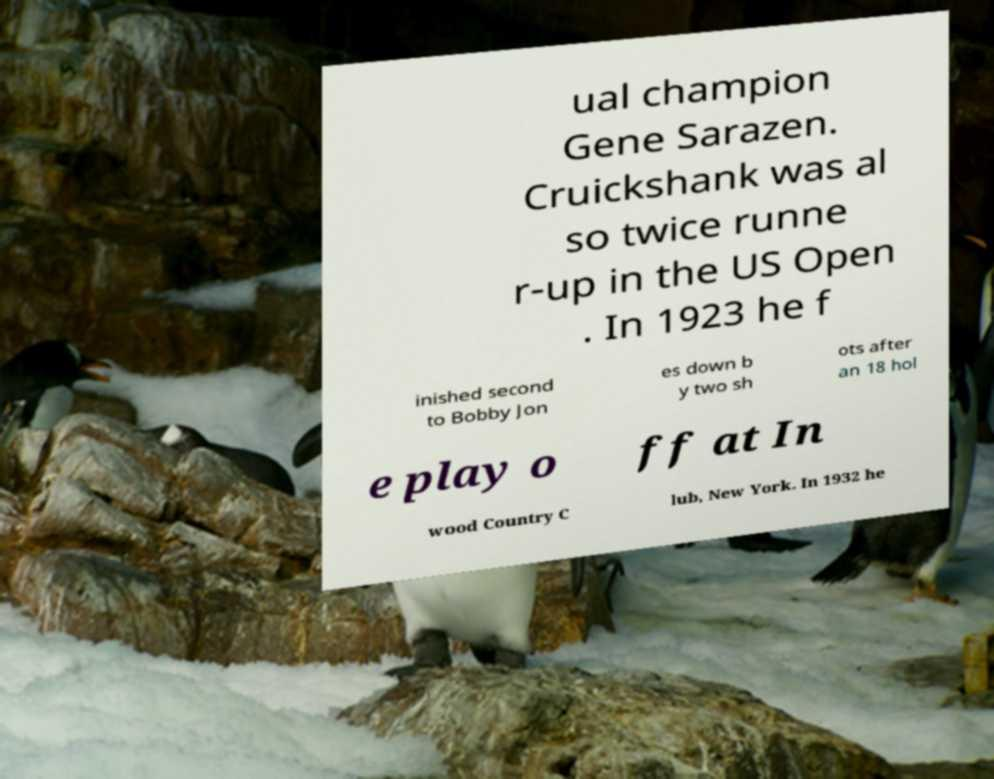Can you accurately transcribe the text from the provided image for me? ual champion Gene Sarazen. Cruickshank was al so twice runne r-up in the US Open . In 1923 he f inished second to Bobby Jon es down b y two sh ots after an 18 hol e play o ff at In wood Country C lub, New York. In 1932 he 